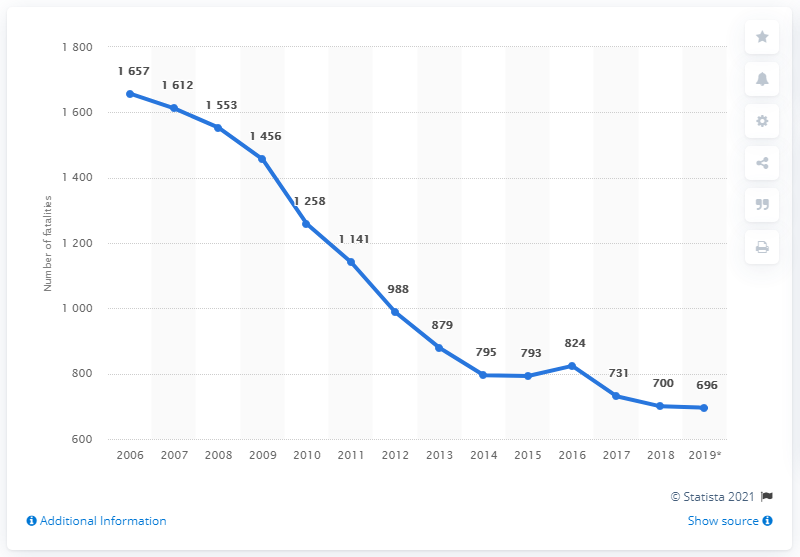What trends can we observe from the road fatality data over the years shown? The chart indicates a clear downward trend in road fatalities from 2006 to 2019. After reaching a peak in 2006, there is a noticeable decline through the following years, with occasional fluctuations such as a slight increase in 2016 before the downward trend continues.  Could you speculate on potential factors that may have contributed to the decrease in road fatalities after 2006? While specifics can't be determined from the chart alone, common contributors to a decrease in road fatalities often include enhanced safety regulations, such as mandatory seat belt use and stricter drink-driving enforcement, improvements in vehicle design like airbags and crumple zones, better driver education programs, and advancements in road infrastructure, such as clearer signage and better traffic flow management. 